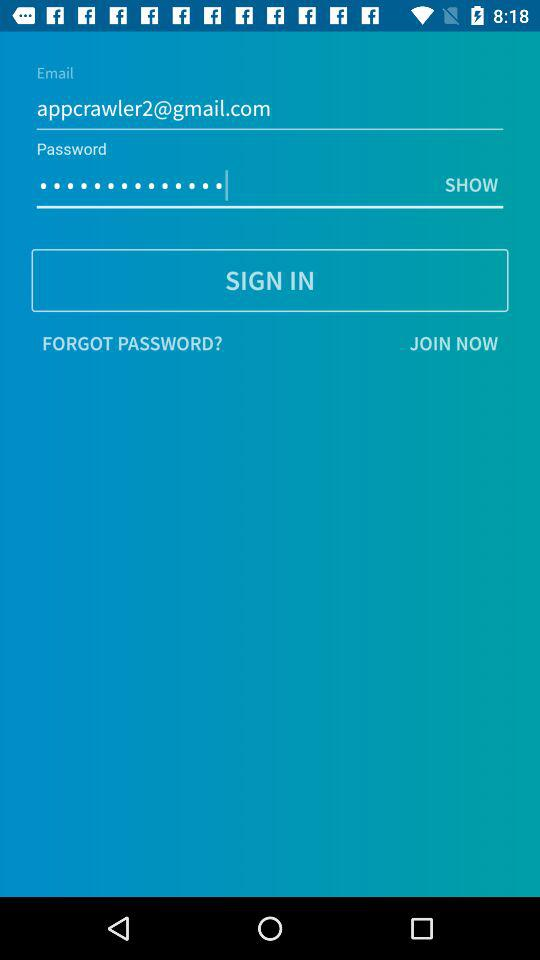What is the email address? The email address is "appcrawler2@gmail.com". 